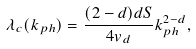<formula> <loc_0><loc_0><loc_500><loc_500>\lambda _ { c } ( k _ { p h } ) = \frac { ( 2 - d ) d S } { 4 v _ { d } } k ^ { 2 - d } _ { p h } ,</formula> 